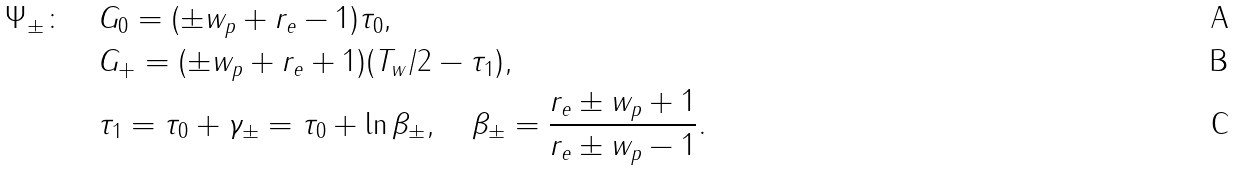<formula> <loc_0><loc_0><loc_500><loc_500>\Psi _ { \pm } \colon \quad & G _ { 0 } = ( \pm w _ { p } + r _ { e } - 1 ) \tau _ { 0 } , \\ & G _ { + } = ( \pm w _ { p } + r _ { e } + 1 ) ( T _ { w } / 2 - \tau _ { 1 } ) , \\ & \tau _ { 1 } = \tau _ { 0 } + \gamma _ { \pm } = \tau _ { 0 } + \ln \beta _ { \pm } , \quad \beta _ { \pm } = \frac { r _ { e } \pm w _ { p } + 1 } { r _ { e } \pm w _ { p } - 1 } .</formula> 